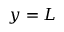<formula> <loc_0><loc_0><loc_500><loc_500>y = L</formula> 